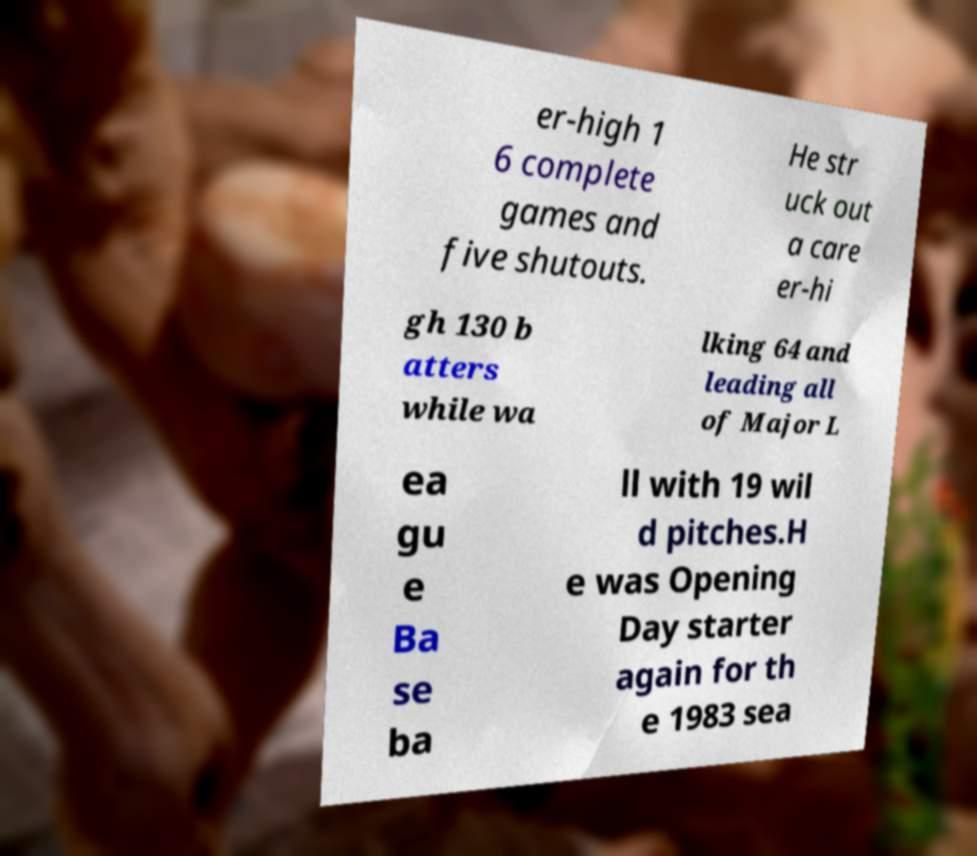Please read and relay the text visible in this image. What does it say? er-high 1 6 complete games and five shutouts. He str uck out a care er-hi gh 130 b atters while wa lking 64 and leading all of Major L ea gu e Ba se ba ll with 19 wil d pitches.H e was Opening Day starter again for th e 1983 sea 